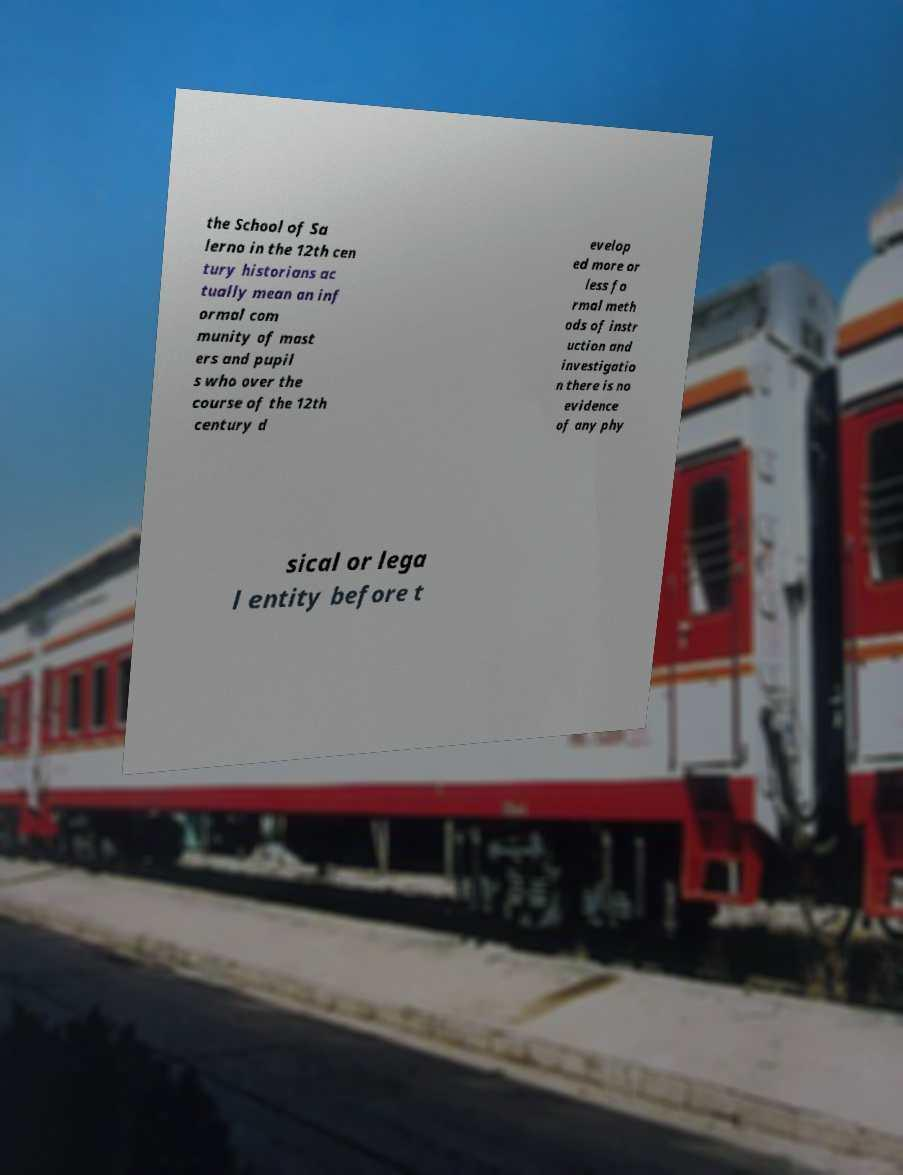There's text embedded in this image that I need extracted. Can you transcribe it verbatim? the School of Sa lerno in the 12th cen tury historians ac tually mean an inf ormal com munity of mast ers and pupil s who over the course of the 12th century d evelop ed more or less fo rmal meth ods of instr uction and investigatio n there is no evidence of any phy sical or lega l entity before t 